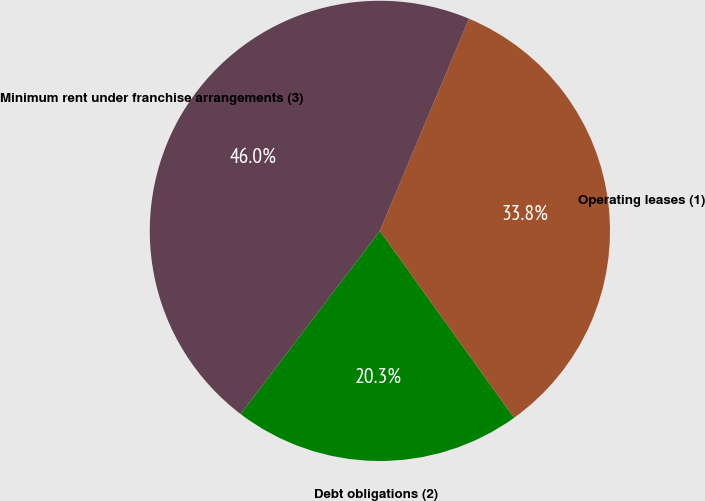Convert chart. <chart><loc_0><loc_0><loc_500><loc_500><pie_chart><fcel>Debt obligations (2)<fcel>Operating leases (1)<fcel>Minimum rent under franchise arrangements (3)<nl><fcel>20.25%<fcel>33.76%<fcel>45.98%<nl></chart> 